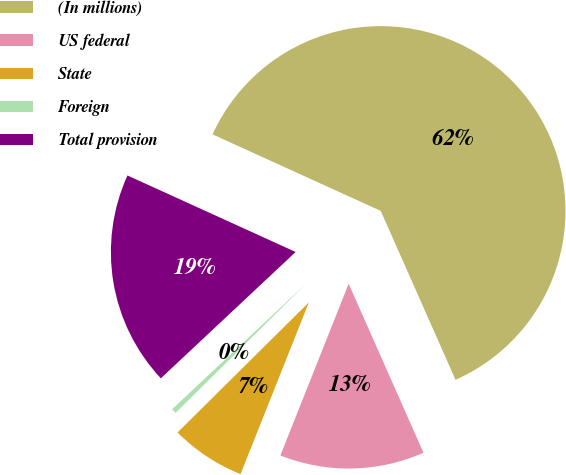<chart> <loc_0><loc_0><loc_500><loc_500><pie_chart><fcel>(In millions)<fcel>US federal<fcel>State<fcel>Foreign<fcel>Total provision<nl><fcel>61.57%<fcel>12.66%<fcel>6.55%<fcel>0.44%<fcel>18.78%<nl></chart> 